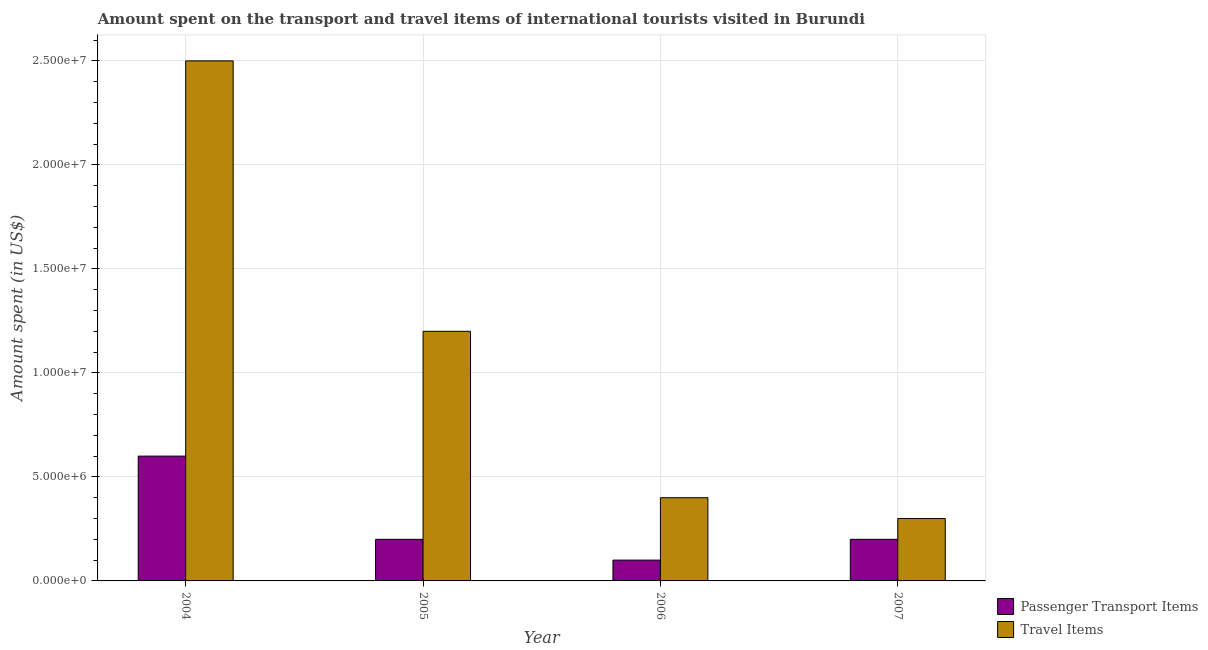Are the number of bars on each tick of the X-axis equal?
Ensure brevity in your answer.  Yes. How many bars are there on the 1st tick from the left?
Offer a terse response. 2. How many bars are there on the 3rd tick from the right?
Make the answer very short. 2. What is the amount spent in travel items in 2006?
Ensure brevity in your answer.  4.00e+06. Across all years, what is the maximum amount spent in travel items?
Your response must be concise. 2.50e+07. Across all years, what is the minimum amount spent in travel items?
Your answer should be very brief. 3.00e+06. In which year was the amount spent in travel items minimum?
Make the answer very short. 2007. What is the total amount spent on passenger transport items in the graph?
Give a very brief answer. 1.10e+07. What is the difference between the amount spent on passenger transport items in 2005 and that in 2006?
Your answer should be compact. 1.00e+06. What is the difference between the amount spent in travel items in 2006 and the amount spent on passenger transport items in 2007?
Provide a succinct answer. 1.00e+06. What is the average amount spent on passenger transport items per year?
Ensure brevity in your answer.  2.75e+06. In how many years, is the amount spent in travel items greater than 23000000 US$?
Ensure brevity in your answer.  1. Is the difference between the amount spent on passenger transport items in 2004 and 2006 greater than the difference between the amount spent in travel items in 2004 and 2006?
Provide a short and direct response. No. What is the difference between the highest and the second highest amount spent in travel items?
Keep it short and to the point. 1.30e+07. What is the difference between the highest and the lowest amount spent on passenger transport items?
Offer a terse response. 5.00e+06. In how many years, is the amount spent in travel items greater than the average amount spent in travel items taken over all years?
Your answer should be very brief. 2. What does the 1st bar from the left in 2004 represents?
Your answer should be compact. Passenger Transport Items. What does the 2nd bar from the right in 2005 represents?
Offer a terse response. Passenger Transport Items. Are all the bars in the graph horizontal?
Provide a succinct answer. No. Does the graph contain any zero values?
Your answer should be compact. No. Does the graph contain grids?
Your answer should be compact. Yes. Where does the legend appear in the graph?
Your answer should be compact. Bottom right. How many legend labels are there?
Provide a succinct answer. 2. What is the title of the graph?
Provide a short and direct response. Amount spent on the transport and travel items of international tourists visited in Burundi. What is the label or title of the Y-axis?
Ensure brevity in your answer.  Amount spent (in US$). What is the Amount spent (in US$) of Travel Items in 2004?
Offer a terse response. 2.50e+07. What is the Amount spent (in US$) in Passenger Transport Items in 2005?
Offer a very short reply. 2.00e+06. What is the Amount spent (in US$) of Passenger Transport Items in 2007?
Your answer should be very brief. 2.00e+06. What is the Amount spent (in US$) of Travel Items in 2007?
Ensure brevity in your answer.  3.00e+06. Across all years, what is the maximum Amount spent (in US$) in Travel Items?
Provide a succinct answer. 2.50e+07. What is the total Amount spent (in US$) in Passenger Transport Items in the graph?
Your response must be concise. 1.10e+07. What is the total Amount spent (in US$) in Travel Items in the graph?
Keep it short and to the point. 4.40e+07. What is the difference between the Amount spent (in US$) of Travel Items in 2004 and that in 2005?
Make the answer very short. 1.30e+07. What is the difference between the Amount spent (in US$) in Passenger Transport Items in 2004 and that in 2006?
Make the answer very short. 5.00e+06. What is the difference between the Amount spent (in US$) in Travel Items in 2004 and that in 2006?
Make the answer very short. 2.10e+07. What is the difference between the Amount spent (in US$) in Passenger Transport Items in 2004 and that in 2007?
Offer a terse response. 4.00e+06. What is the difference between the Amount spent (in US$) of Travel Items in 2004 and that in 2007?
Ensure brevity in your answer.  2.20e+07. What is the difference between the Amount spent (in US$) of Travel Items in 2005 and that in 2006?
Your response must be concise. 8.00e+06. What is the difference between the Amount spent (in US$) of Passenger Transport Items in 2005 and that in 2007?
Offer a terse response. 0. What is the difference between the Amount spent (in US$) in Travel Items in 2005 and that in 2007?
Give a very brief answer. 9.00e+06. What is the difference between the Amount spent (in US$) in Travel Items in 2006 and that in 2007?
Offer a terse response. 1.00e+06. What is the difference between the Amount spent (in US$) of Passenger Transport Items in 2004 and the Amount spent (in US$) of Travel Items in 2005?
Keep it short and to the point. -6.00e+06. What is the difference between the Amount spent (in US$) of Passenger Transport Items in 2004 and the Amount spent (in US$) of Travel Items in 2007?
Your answer should be very brief. 3.00e+06. What is the difference between the Amount spent (in US$) in Passenger Transport Items in 2006 and the Amount spent (in US$) in Travel Items in 2007?
Ensure brevity in your answer.  -2.00e+06. What is the average Amount spent (in US$) of Passenger Transport Items per year?
Ensure brevity in your answer.  2.75e+06. What is the average Amount spent (in US$) of Travel Items per year?
Ensure brevity in your answer.  1.10e+07. In the year 2004, what is the difference between the Amount spent (in US$) of Passenger Transport Items and Amount spent (in US$) of Travel Items?
Your answer should be compact. -1.90e+07. In the year 2005, what is the difference between the Amount spent (in US$) of Passenger Transport Items and Amount spent (in US$) of Travel Items?
Your answer should be very brief. -1.00e+07. In the year 2006, what is the difference between the Amount spent (in US$) in Passenger Transport Items and Amount spent (in US$) in Travel Items?
Provide a succinct answer. -3.00e+06. In the year 2007, what is the difference between the Amount spent (in US$) in Passenger Transport Items and Amount spent (in US$) in Travel Items?
Give a very brief answer. -1.00e+06. What is the ratio of the Amount spent (in US$) in Passenger Transport Items in 2004 to that in 2005?
Provide a succinct answer. 3. What is the ratio of the Amount spent (in US$) in Travel Items in 2004 to that in 2005?
Provide a short and direct response. 2.08. What is the ratio of the Amount spent (in US$) of Travel Items in 2004 to that in 2006?
Provide a short and direct response. 6.25. What is the ratio of the Amount spent (in US$) of Travel Items in 2004 to that in 2007?
Ensure brevity in your answer.  8.33. What is the ratio of the Amount spent (in US$) of Travel Items in 2005 to that in 2006?
Your answer should be compact. 3. What is the ratio of the Amount spent (in US$) in Passenger Transport Items in 2006 to that in 2007?
Offer a terse response. 0.5. What is the ratio of the Amount spent (in US$) of Travel Items in 2006 to that in 2007?
Ensure brevity in your answer.  1.33. What is the difference between the highest and the second highest Amount spent (in US$) of Passenger Transport Items?
Keep it short and to the point. 4.00e+06. What is the difference between the highest and the second highest Amount spent (in US$) of Travel Items?
Give a very brief answer. 1.30e+07. What is the difference between the highest and the lowest Amount spent (in US$) of Passenger Transport Items?
Your response must be concise. 5.00e+06. What is the difference between the highest and the lowest Amount spent (in US$) in Travel Items?
Make the answer very short. 2.20e+07. 